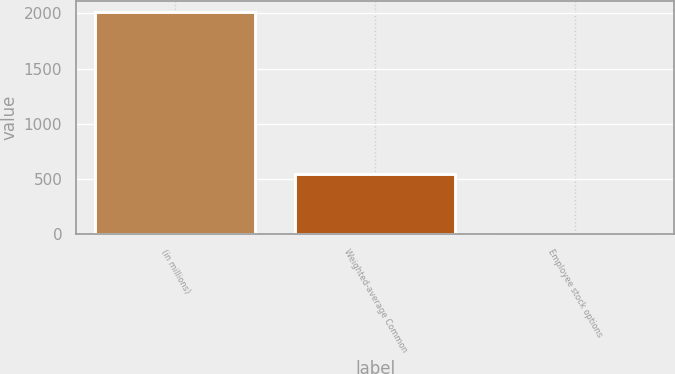<chart> <loc_0><loc_0><loc_500><loc_500><bar_chart><fcel>(in millions)<fcel>Weighted-average Common<fcel>Employee stock options<nl><fcel>2012<fcel>545.8<fcel>4<nl></chart> 